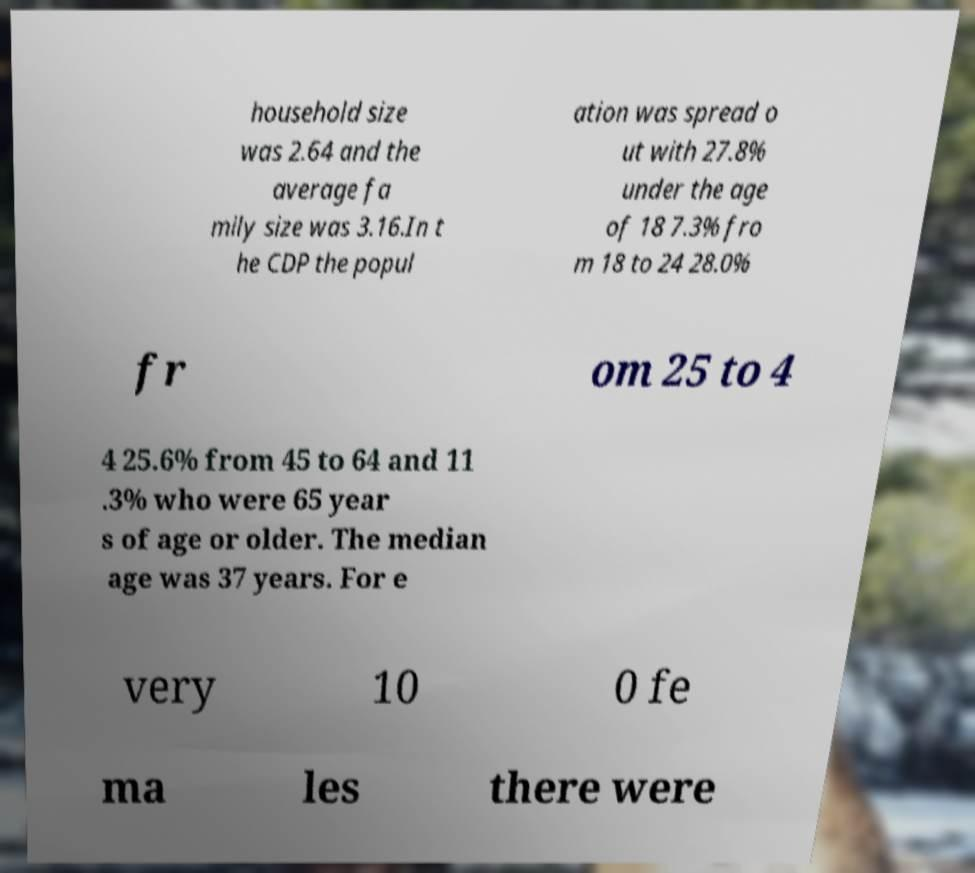Please identify and transcribe the text found in this image. household size was 2.64 and the average fa mily size was 3.16.In t he CDP the popul ation was spread o ut with 27.8% under the age of 18 7.3% fro m 18 to 24 28.0% fr om 25 to 4 4 25.6% from 45 to 64 and 11 .3% who were 65 year s of age or older. The median age was 37 years. For e very 10 0 fe ma les there were 